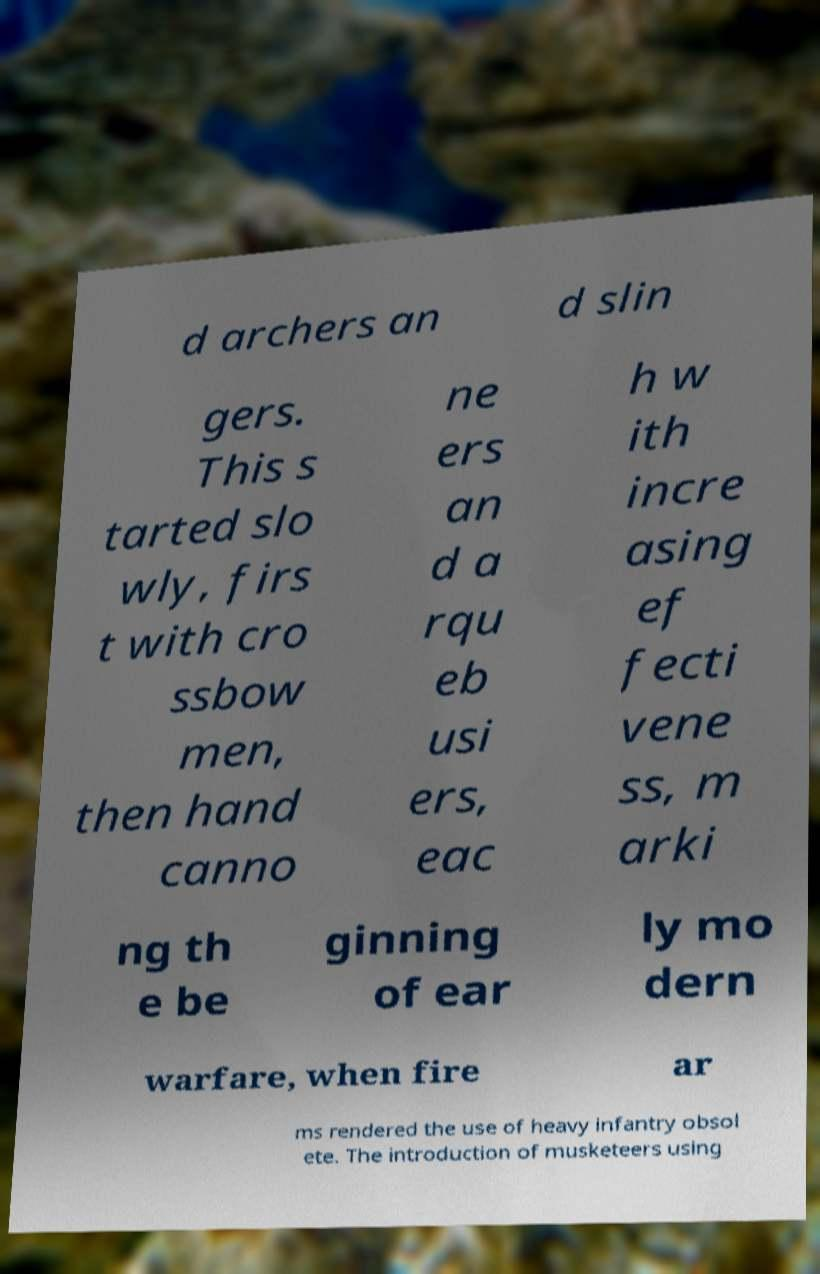I need the written content from this picture converted into text. Can you do that? d archers an d slin gers. This s tarted slo wly, firs t with cro ssbow men, then hand canno ne ers an d a rqu eb usi ers, eac h w ith incre asing ef fecti vene ss, m arki ng th e be ginning of ear ly mo dern warfare, when fire ar ms rendered the use of heavy infantry obsol ete. The introduction of musketeers using 